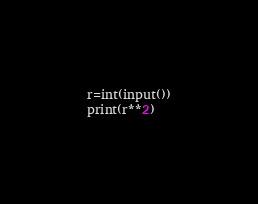Convert code to text. <code><loc_0><loc_0><loc_500><loc_500><_Python_>r=int(input())
print(r**2)</code> 